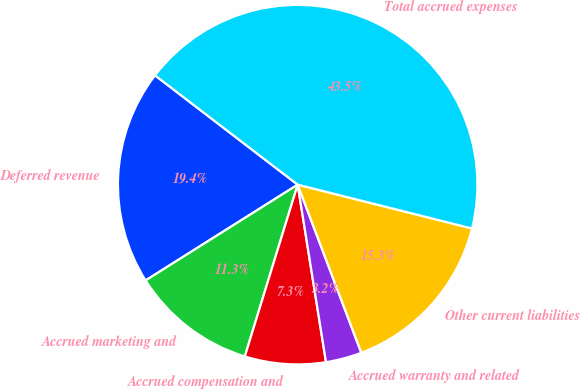Convert chart. <chart><loc_0><loc_0><loc_500><loc_500><pie_chart><fcel>Deferred revenue<fcel>Accrued marketing and<fcel>Accrued compensation and<fcel>Accrued warranty and related<fcel>Other current liabilities<fcel>Total accrued expenses<nl><fcel>19.35%<fcel>11.3%<fcel>7.27%<fcel>3.24%<fcel>15.32%<fcel>43.51%<nl></chart> 